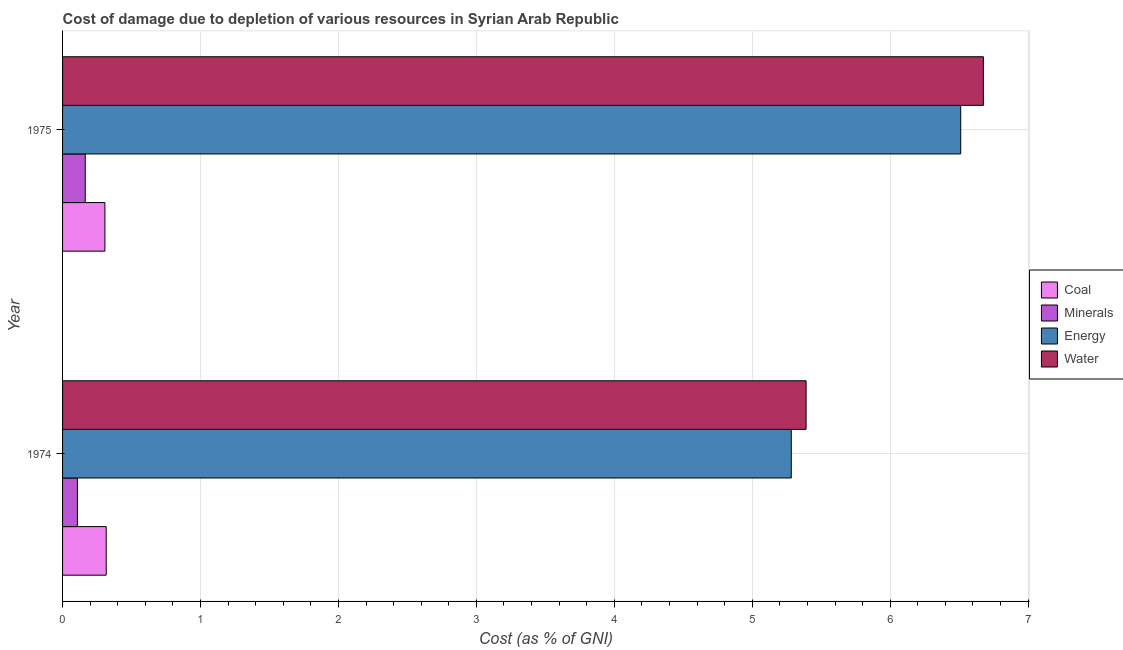How many groups of bars are there?
Offer a very short reply. 2. How many bars are there on the 1st tick from the top?
Make the answer very short. 4. How many bars are there on the 2nd tick from the bottom?
Offer a very short reply. 4. What is the label of the 1st group of bars from the top?
Give a very brief answer. 1975. In how many cases, is the number of bars for a given year not equal to the number of legend labels?
Provide a short and direct response. 0. What is the cost of damage due to depletion of water in 1975?
Offer a terse response. 6.68. Across all years, what is the maximum cost of damage due to depletion of water?
Provide a short and direct response. 6.68. Across all years, what is the minimum cost of damage due to depletion of minerals?
Provide a succinct answer. 0.11. In which year was the cost of damage due to depletion of water maximum?
Make the answer very short. 1975. In which year was the cost of damage due to depletion of minerals minimum?
Your response must be concise. 1974. What is the total cost of damage due to depletion of minerals in the graph?
Your response must be concise. 0.27. What is the difference between the cost of damage due to depletion of minerals in 1974 and that in 1975?
Your response must be concise. -0.06. What is the difference between the cost of damage due to depletion of energy in 1974 and the cost of damage due to depletion of minerals in 1975?
Offer a terse response. 5.12. What is the average cost of damage due to depletion of energy per year?
Make the answer very short. 5.9. In the year 1974, what is the difference between the cost of damage due to depletion of water and cost of damage due to depletion of coal?
Provide a short and direct response. 5.07. In how many years, is the cost of damage due to depletion of energy greater than 1 %?
Keep it short and to the point. 2. What is the ratio of the cost of damage due to depletion of minerals in 1974 to that in 1975?
Your answer should be very brief. 0.65. Is the difference between the cost of damage due to depletion of energy in 1974 and 1975 greater than the difference between the cost of damage due to depletion of water in 1974 and 1975?
Keep it short and to the point. Yes. Is it the case that in every year, the sum of the cost of damage due to depletion of water and cost of damage due to depletion of minerals is greater than the sum of cost of damage due to depletion of coal and cost of damage due to depletion of energy?
Provide a succinct answer. No. What does the 4th bar from the top in 1974 represents?
Provide a short and direct response. Coal. What does the 4th bar from the bottom in 1974 represents?
Offer a terse response. Water. How many bars are there?
Provide a succinct answer. 8. Are all the bars in the graph horizontal?
Your response must be concise. Yes. How many years are there in the graph?
Ensure brevity in your answer.  2. What is the difference between two consecutive major ticks on the X-axis?
Offer a terse response. 1. How many legend labels are there?
Provide a short and direct response. 4. How are the legend labels stacked?
Your answer should be compact. Vertical. What is the title of the graph?
Your answer should be very brief. Cost of damage due to depletion of various resources in Syrian Arab Republic . Does "Ease of arranging shipments" appear as one of the legend labels in the graph?
Your answer should be very brief. No. What is the label or title of the X-axis?
Offer a terse response. Cost (as % of GNI). What is the Cost (as % of GNI) in Coal in 1974?
Provide a succinct answer. 0.32. What is the Cost (as % of GNI) in Minerals in 1974?
Offer a very short reply. 0.11. What is the Cost (as % of GNI) in Energy in 1974?
Your response must be concise. 5.28. What is the Cost (as % of GNI) of Water in 1974?
Offer a terse response. 5.39. What is the Cost (as % of GNI) in Coal in 1975?
Keep it short and to the point. 0.31. What is the Cost (as % of GNI) of Minerals in 1975?
Give a very brief answer. 0.16. What is the Cost (as % of GNI) in Energy in 1975?
Offer a very short reply. 6.51. What is the Cost (as % of GNI) of Water in 1975?
Your response must be concise. 6.68. Across all years, what is the maximum Cost (as % of GNI) of Coal?
Your answer should be very brief. 0.32. Across all years, what is the maximum Cost (as % of GNI) in Minerals?
Offer a very short reply. 0.16. Across all years, what is the maximum Cost (as % of GNI) of Energy?
Make the answer very short. 6.51. Across all years, what is the maximum Cost (as % of GNI) in Water?
Offer a terse response. 6.68. Across all years, what is the minimum Cost (as % of GNI) in Coal?
Provide a short and direct response. 0.31. Across all years, what is the minimum Cost (as % of GNI) in Minerals?
Provide a succinct answer. 0.11. Across all years, what is the minimum Cost (as % of GNI) of Energy?
Offer a very short reply. 5.28. Across all years, what is the minimum Cost (as % of GNI) of Water?
Make the answer very short. 5.39. What is the total Cost (as % of GNI) of Coal in the graph?
Make the answer very short. 0.62. What is the total Cost (as % of GNI) in Minerals in the graph?
Offer a terse response. 0.27. What is the total Cost (as % of GNI) in Energy in the graph?
Ensure brevity in your answer.  11.79. What is the total Cost (as % of GNI) in Water in the graph?
Make the answer very short. 12.07. What is the difference between the Cost (as % of GNI) in Coal in 1974 and that in 1975?
Make the answer very short. 0.01. What is the difference between the Cost (as % of GNI) of Minerals in 1974 and that in 1975?
Your answer should be very brief. -0.06. What is the difference between the Cost (as % of GNI) of Energy in 1974 and that in 1975?
Ensure brevity in your answer.  -1.23. What is the difference between the Cost (as % of GNI) in Water in 1974 and that in 1975?
Your response must be concise. -1.29. What is the difference between the Cost (as % of GNI) in Coal in 1974 and the Cost (as % of GNI) in Minerals in 1975?
Offer a very short reply. 0.15. What is the difference between the Cost (as % of GNI) in Coal in 1974 and the Cost (as % of GNI) in Energy in 1975?
Offer a very short reply. -6.19. What is the difference between the Cost (as % of GNI) in Coal in 1974 and the Cost (as % of GNI) in Water in 1975?
Ensure brevity in your answer.  -6.36. What is the difference between the Cost (as % of GNI) of Minerals in 1974 and the Cost (as % of GNI) of Energy in 1975?
Offer a very short reply. -6.4. What is the difference between the Cost (as % of GNI) in Minerals in 1974 and the Cost (as % of GNI) in Water in 1975?
Your answer should be very brief. -6.57. What is the difference between the Cost (as % of GNI) of Energy in 1974 and the Cost (as % of GNI) of Water in 1975?
Keep it short and to the point. -1.39. What is the average Cost (as % of GNI) of Coal per year?
Provide a succinct answer. 0.31. What is the average Cost (as % of GNI) of Minerals per year?
Your answer should be compact. 0.14. What is the average Cost (as % of GNI) of Energy per year?
Offer a very short reply. 5.9. What is the average Cost (as % of GNI) of Water per year?
Keep it short and to the point. 6.03. In the year 1974, what is the difference between the Cost (as % of GNI) in Coal and Cost (as % of GNI) in Minerals?
Keep it short and to the point. 0.21. In the year 1974, what is the difference between the Cost (as % of GNI) in Coal and Cost (as % of GNI) in Energy?
Make the answer very short. -4.97. In the year 1974, what is the difference between the Cost (as % of GNI) of Coal and Cost (as % of GNI) of Water?
Make the answer very short. -5.07. In the year 1974, what is the difference between the Cost (as % of GNI) of Minerals and Cost (as % of GNI) of Energy?
Your answer should be compact. -5.18. In the year 1974, what is the difference between the Cost (as % of GNI) in Minerals and Cost (as % of GNI) in Water?
Your answer should be very brief. -5.28. In the year 1974, what is the difference between the Cost (as % of GNI) of Energy and Cost (as % of GNI) of Water?
Ensure brevity in your answer.  -0.11. In the year 1975, what is the difference between the Cost (as % of GNI) in Coal and Cost (as % of GNI) in Minerals?
Give a very brief answer. 0.14. In the year 1975, what is the difference between the Cost (as % of GNI) in Coal and Cost (as % of GNI) in Energy?
Offer a very short reply. -6.2. In the year 1975, what is the difference between the Cost (as % of GNI) in Coal and Cost (as % of GNI) in Water?
Offer a terse response. -6.37. In the year 1975, what is the difference between the Cost (as % of GNI) in Minerals and Cost (as % of GNI) in Energy?
Provide a short and direct response. -6.35. In the year 1975, what is the difference between the Cost (as % of GNI) in Minerals and Cost (as % of GNI) in Water?
Provide a short and direct response. -6.51. In the year 1975, what is the difference between the Cost (as % of GNI) of Energy and Cost (as % of GNI) of Water?
Provide a succinct answer. -0.16. What is the ratio of the Cost (as % of GNI) of Coal in 1974 to that in 1975?
Keep it short and to the point. 1.03. What is the ratio of the Cost (as % of GNI) of Minerals in 1974 to that in 1975?
Your answer should be very brief. 0.65. What is the ratio of the Cost (as % of GNI) in Energy in 1974 to that in 1975?
Make the answer very short. 0.81. What is the ratio of the Cost (as % of GNI) of Water in 1974 to that in 1975?
Offer a terse response. 0.81. What is the difference between the highest and the second highest Cost (as % of GNI) of Coal?
Keep it short and to the point. 0.01. What is the difference between the highest and the second highest Cost (as % of GNI) in Minerals?
Your response must be concise. 0.06. What is the difference between the highest and the second highest Cost (as % of GNI) in Energy?
Your answer should be compact. 1.23. What is the difference between the highest and the second highest Cost (as % of GNI) in Water?
Give a very brief answer. 1.29. What is the difference between the highest and the lowest Cost (as % of GNI) of Coal?
Provide a short and direct response. 0.01. What is the difference between the highest and the lowest Cost (as % of GNI) in Minerals?
Your answer should be very brief. 0.06. What is the difference between the highest and the lowest Cost (as % of GNI) of Energy?
Provide a short and direct response. 1.23. What is the difference between the highest and the lowest Cost (as % of GNI) in Water?
Your answer should be very brief. 1.29. 